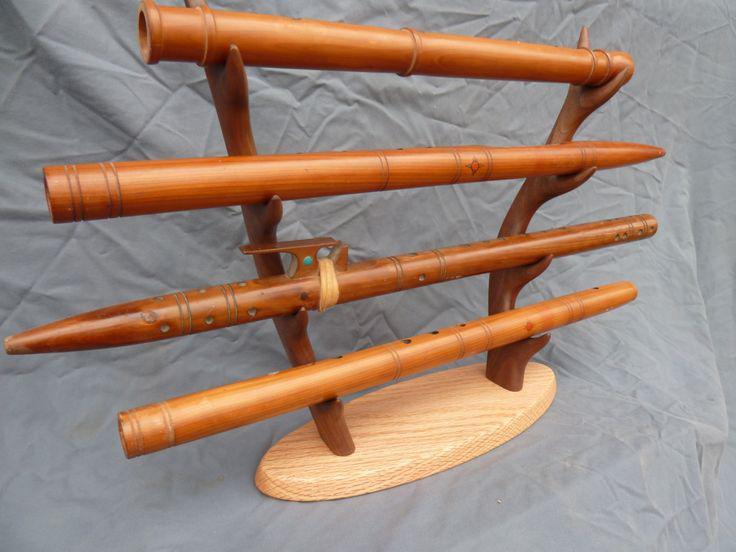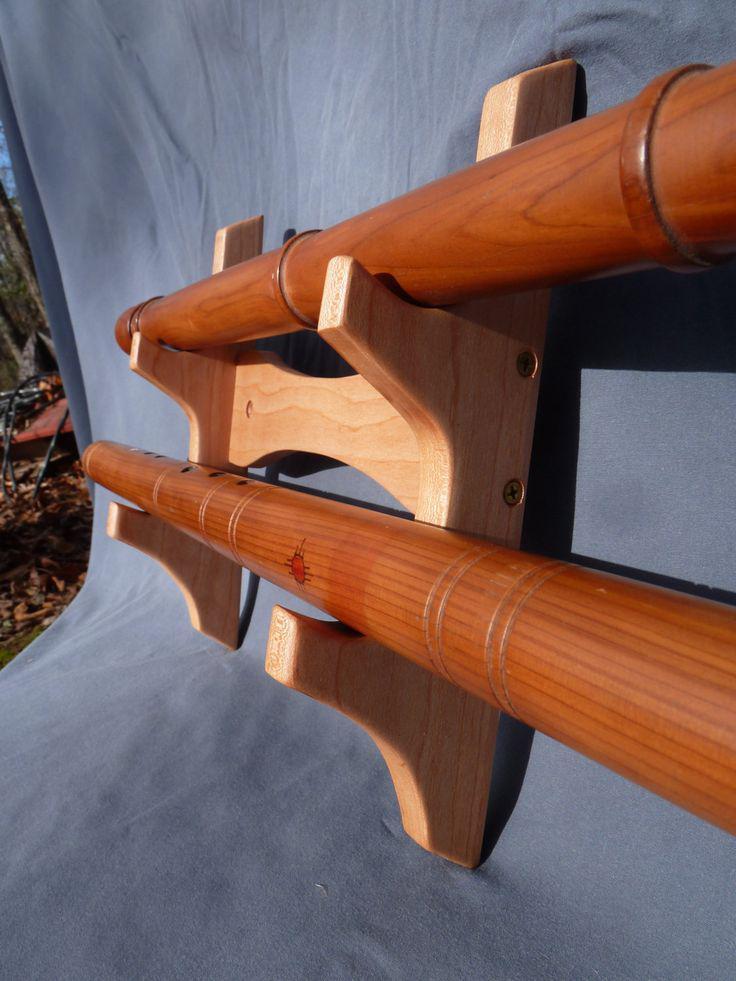The first image is the image on the left, the second image is the image on the right. Assess this claim about the two images: "There are more instruments in the image on the right.". Correct or not? Answer yes or no. No. The first image is the image on the left, the second image is the image on the right. Analyze the images presented: Is the assertion "Each image features a wooden holder that displays flutes horizontally, and one of the flute holders stands upright on an oval base." valid? Answer yes or no. Yes. 